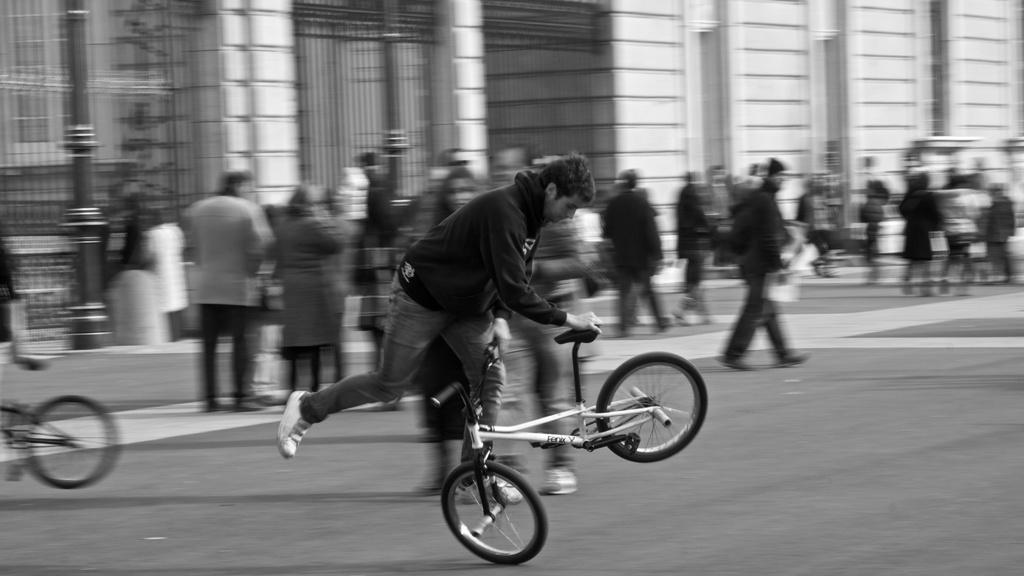Who is the main subject in the image? There is a man in the image. What is the man doing in the image? The man is playing with a small bicycle. Where is the man located in the image? The man is on a road. Are there any other people in the image? Yes, there are people walking behind him. What type of cat can be seen playing with the man in the image? There is no cat present in the image; the man is playing with a small bicycle. 